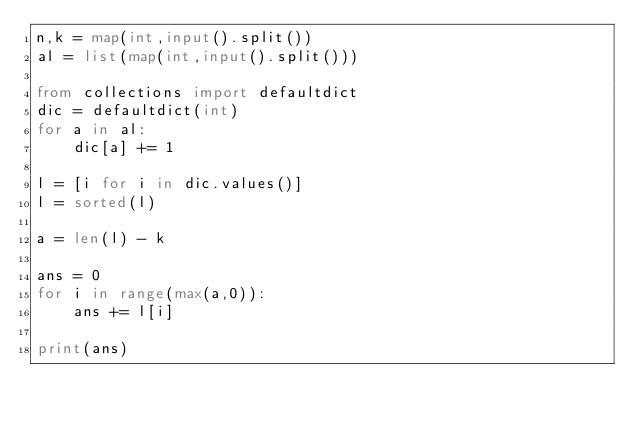Convert code to text. <code><loc_0><loc_0><loc_500><loc_500><_Python_>n,k = map(int,input().split())
al = list(map(int,input().split()))

from collections import defaultdict
dic = defaultdict(int)
for a in al:
    dic[a] += 1

l = [i for i in dic.values()]
l = sorted(l)

a = len(l) - k

ans = 0
for i in range(max(a,0)):
    ans += l[i]

print(ans)</code> 